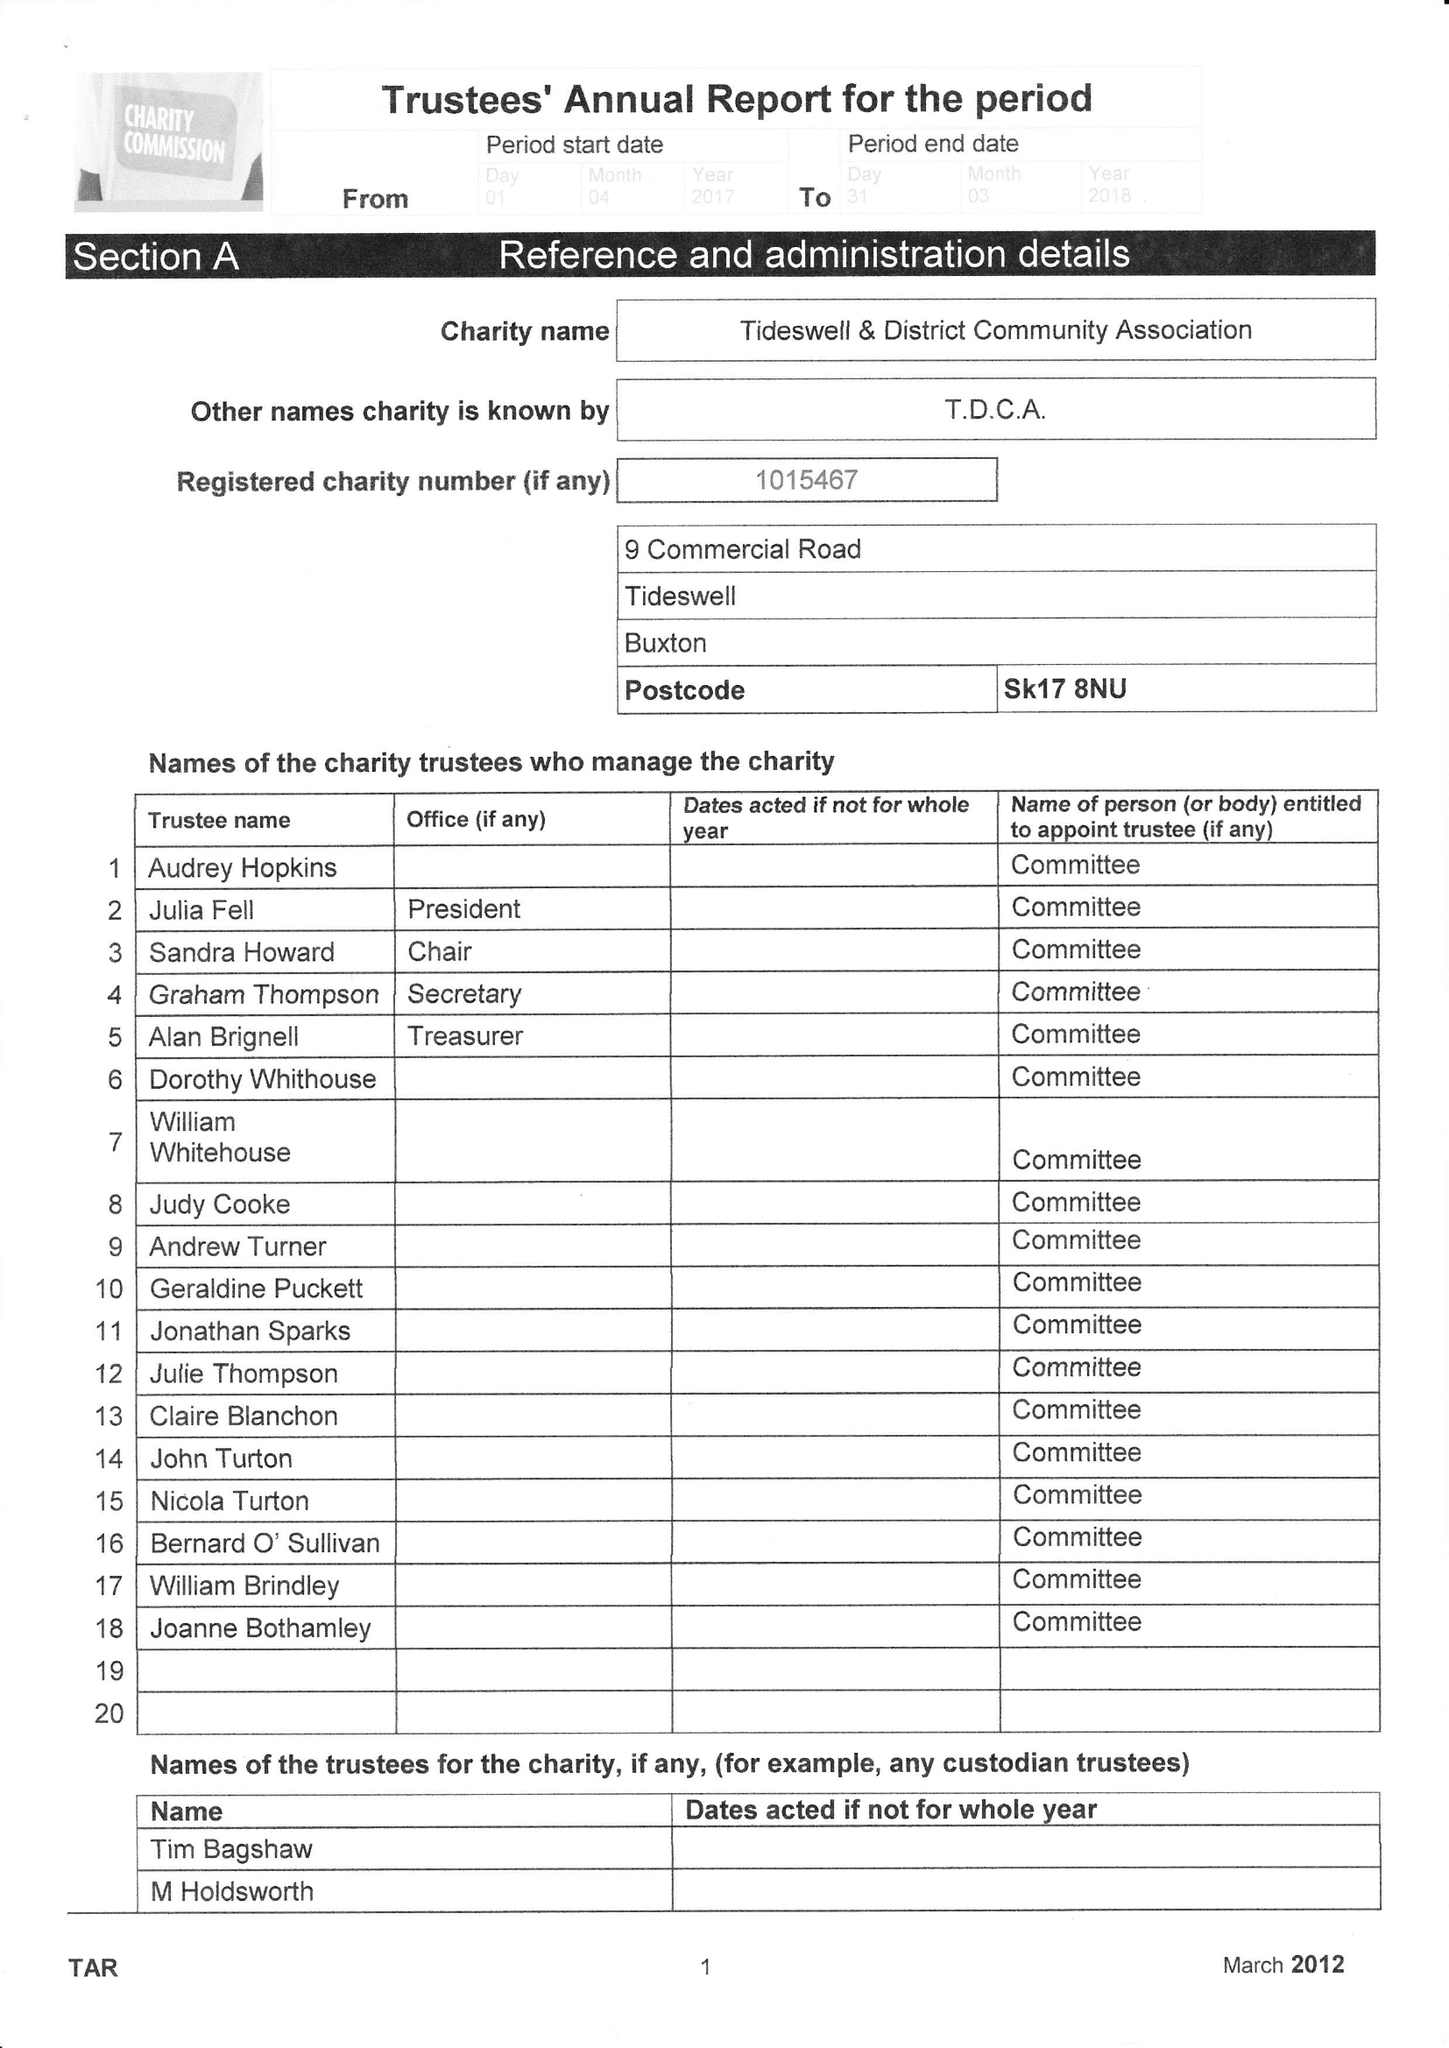What is the value for the charity_number?
Answer the question using a single word or phrase. 1015467 